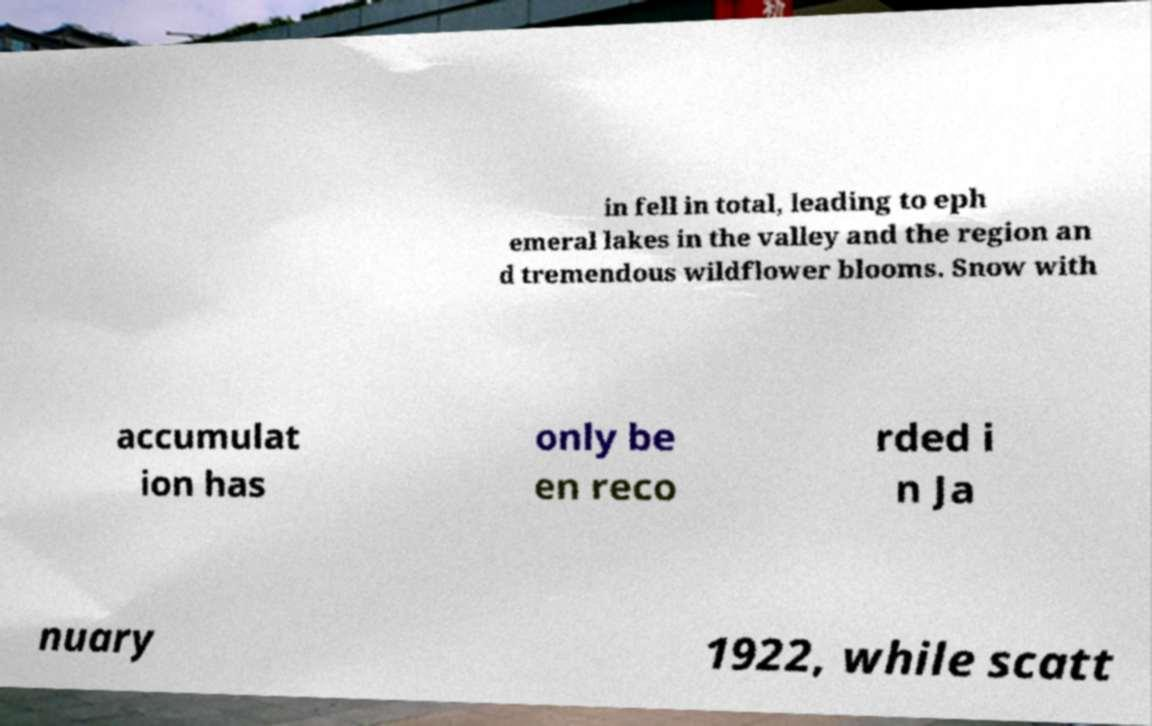I need the written content from this picture converted into text. Can you do that? in fell in total, leading to eph emeral lakes in the valley and the region an d tremendous wildflower blooms. Snow with accumulat ion has only be en reco rded i n Ja nuary 1922, while scatt 